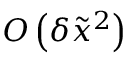<formula> <loc_0><loc_0><loc_500><loc_500>O \left ( { \delta { { \tilde { x } } ^ { 2 } } } \right )</formula> 